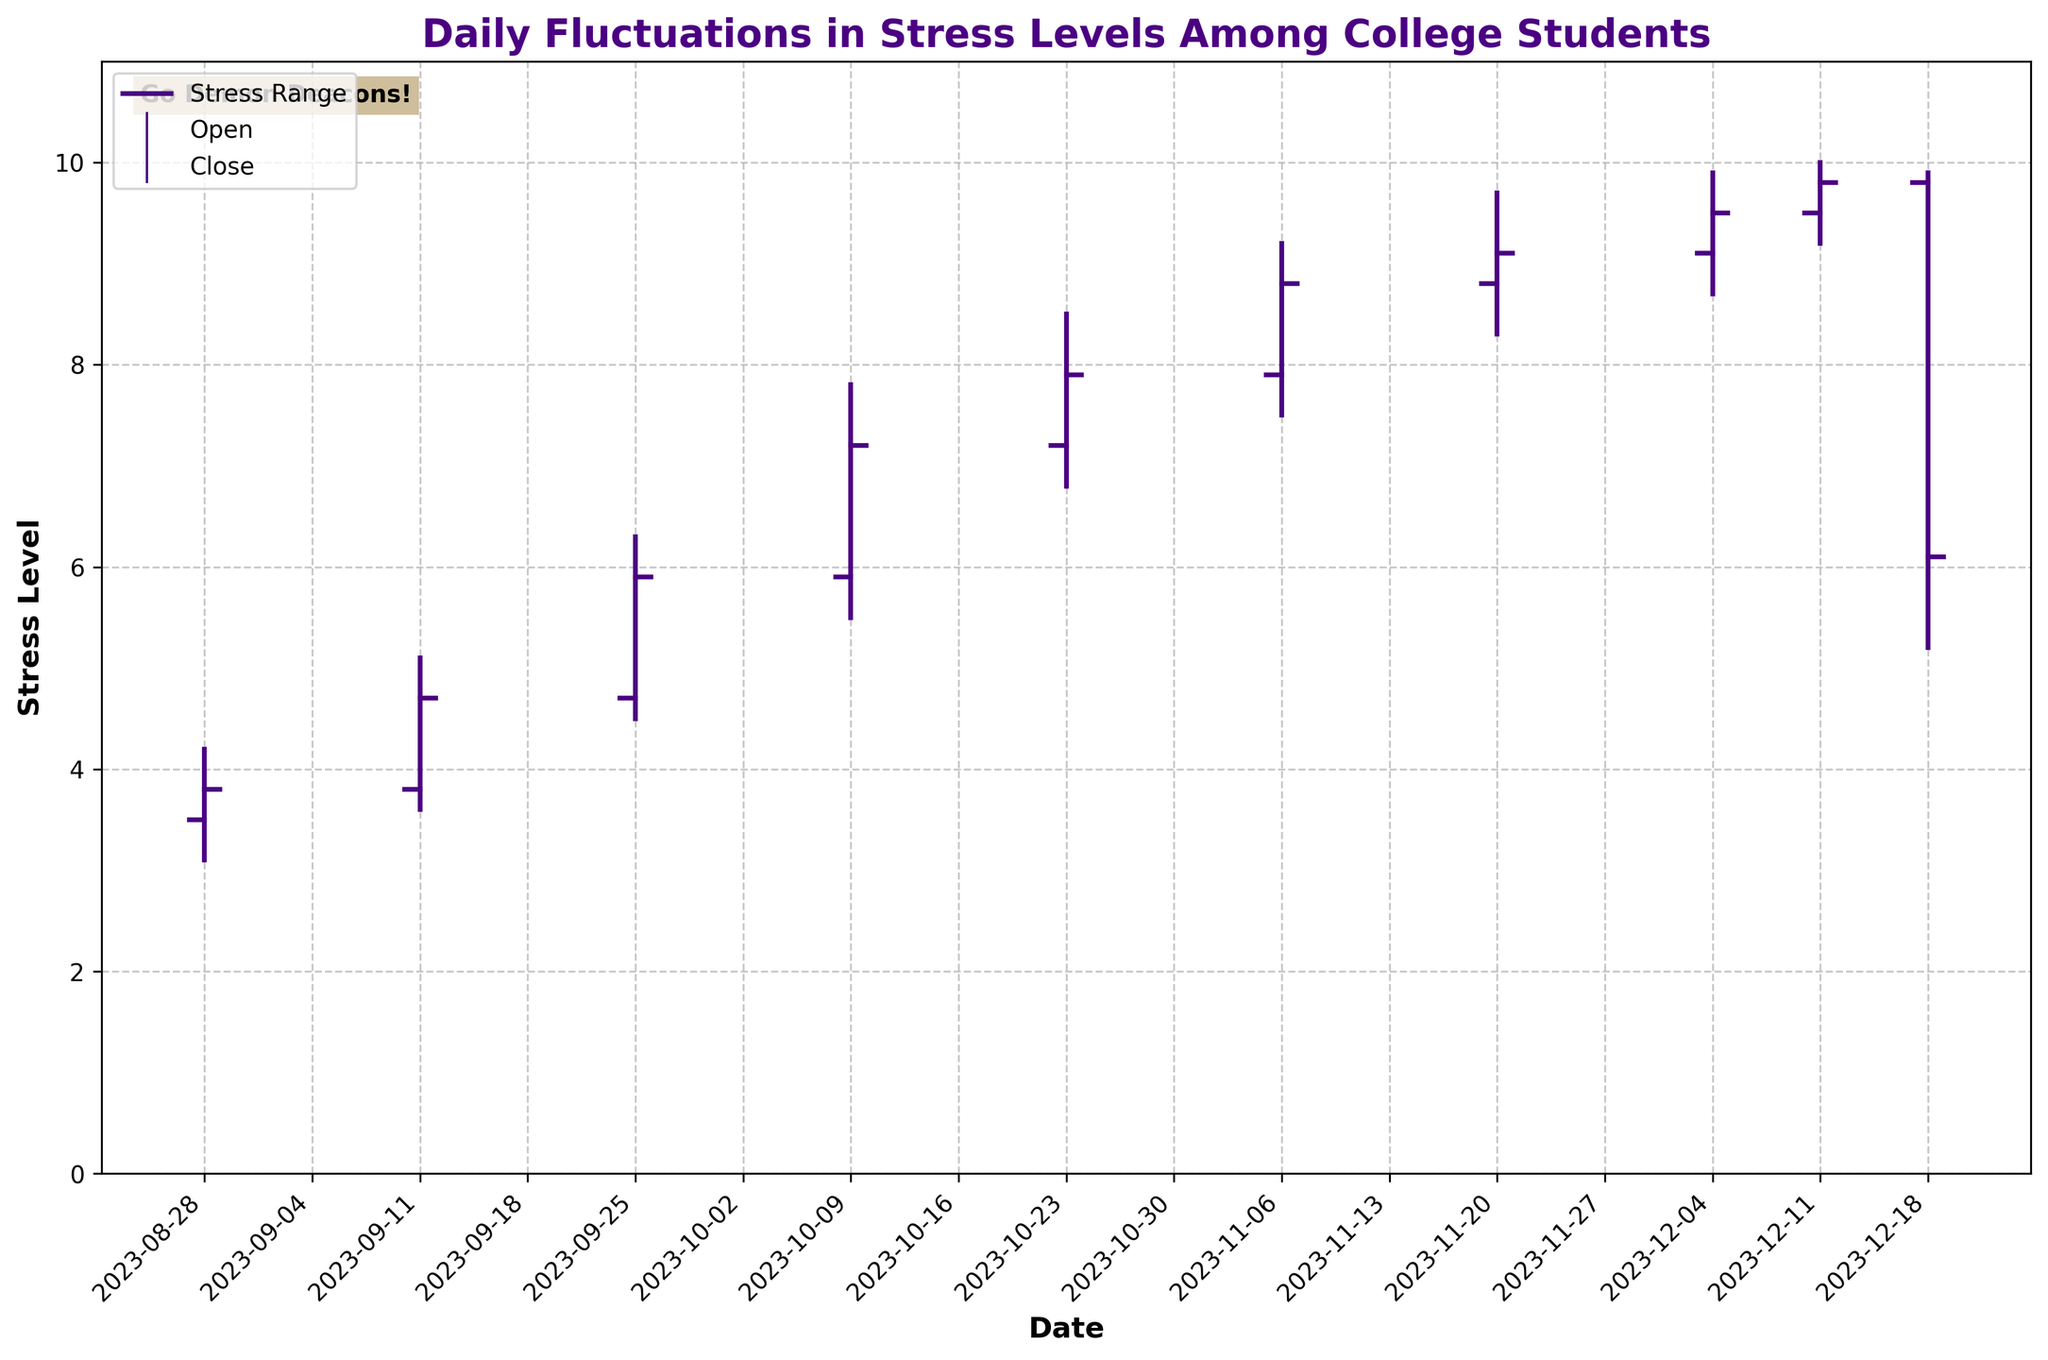What is the date range covered in the figure? The figure shows dates starting from 2023-08-28 to 2023-12-18. This is evident from the labels on the x-axis.
Answer: 2023-08-28 to 2023-12-18 How does the stress level trend from August to December? Observing the figure, the general trend is an increase in stress levels from late August to mid-December, peaking in the middle of December before dropping drastically in the last data point.
Answer: Increasing till mid-December, then a drop What is the highest recorded stress level on any given day in the figure? The highest recorded stress level is shown by the highest 'High' value on the y-axis, which is 10.0. This occurs on 2023-12-11.
Answer: 10.0 Which date shows the most significant drop in stress level from opening to close? The date with the most significant drop is 2023-12-18. The opening stress level was 9.8, but it dropped to 6.1 at close.
Answer: 2023-12-18 What was the opening stress level on 2023-09-11 and how does it compare to its closing stress level on the same day? The opening stress level on 2023-09-11 was 3.8 and the closing stress level was 4.7. This shows an increase from open to close.
Answer: Opening: 3.8, Closing: 4.7 Calculate the average closing stress level in October. The dates in October are 2023-10-09 and 2023-10-23, with closing stress levels of 7.2 and 7.9 respectively. The average is (7.2 + 7.9)/2 = 7.55.
Answer: 7.55 Which date has the highest volatility in stress level measured by the difference between high and low stress levels? The date with the greatest difference between high and low stress levels is 2023-12-18, where the high is 9.9 and the low is 5.2, making the volatility 4.7.
Answer: 2023-12-18 What is the lowest recorded stress level throughout the semester? The lowest recorded stress level is the lowest 'Low' value visible on the y-axis, which is 3.1 on 2023-08-28.
Answer: 3.1 Compare the range of stress levels (high minus low) on 2023-10-23 and 2023-11-20. Which day had a larger range? On 2023-10-23, the range is 8.5 - 6.8 = 1.7. On 2023-11-20, the range is 9.7 - 8.3 = 1.4. Therefore, 2023-10-23 had a larger range.
Answer: 2023-10-23 What is the difference in stress levels between the opening and closing on 2023-12-11? The opening stress level on 2023-12-11 was 9.5 and the closing stress level was 9.8. The difference is 9.8 - 9.5 = 0.3.
Answer: 0.3 